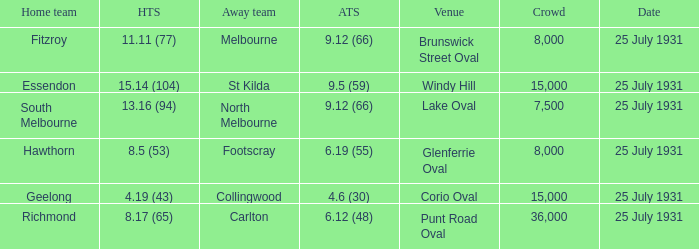When the home team was fitzroy, what did the away team score? 9.12 (66). 